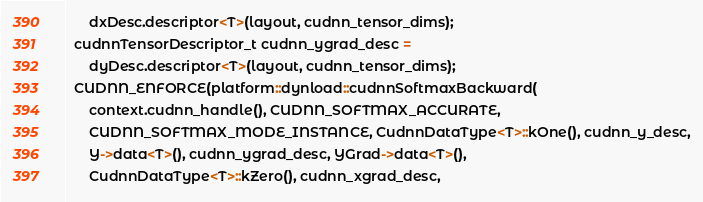Convert code to text. <code><loc_0><loc_0><loc_500><loc_500><_Cuda_>      dxDesc.descriptor<T>(layout, cudnn_tensor_dims);
  cudnnTensorDescriptor_t cudnn_ygrad_desc =
      dyDesc.descriptor<T>(layout, cudnn_tensor_dims);
  CUDNN_ENFORCE(platform::dynload::cudnnSoftmaxBackward(
      context.cudnn_handle(), CUDNN_SOFTMAX_ACCURATE,
      CUDNN_SOFTMAX_MODE_INSTANCE, CudnnDataType<T>::kOne(), cudnn_y_desc,
      Y->data<T>(), cudnn_ygrad_desc, YGrad->data<T>(),
      CudnnDataType<T>::kZero(), cudnn_xgrad_desc,</code> 